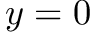<formula> <loc_0><loc_0><loc_500><loc_500>y = 0</formula> 